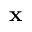<formula> <loc_0><loc_0><loc_500><loc_500>x</formula> 